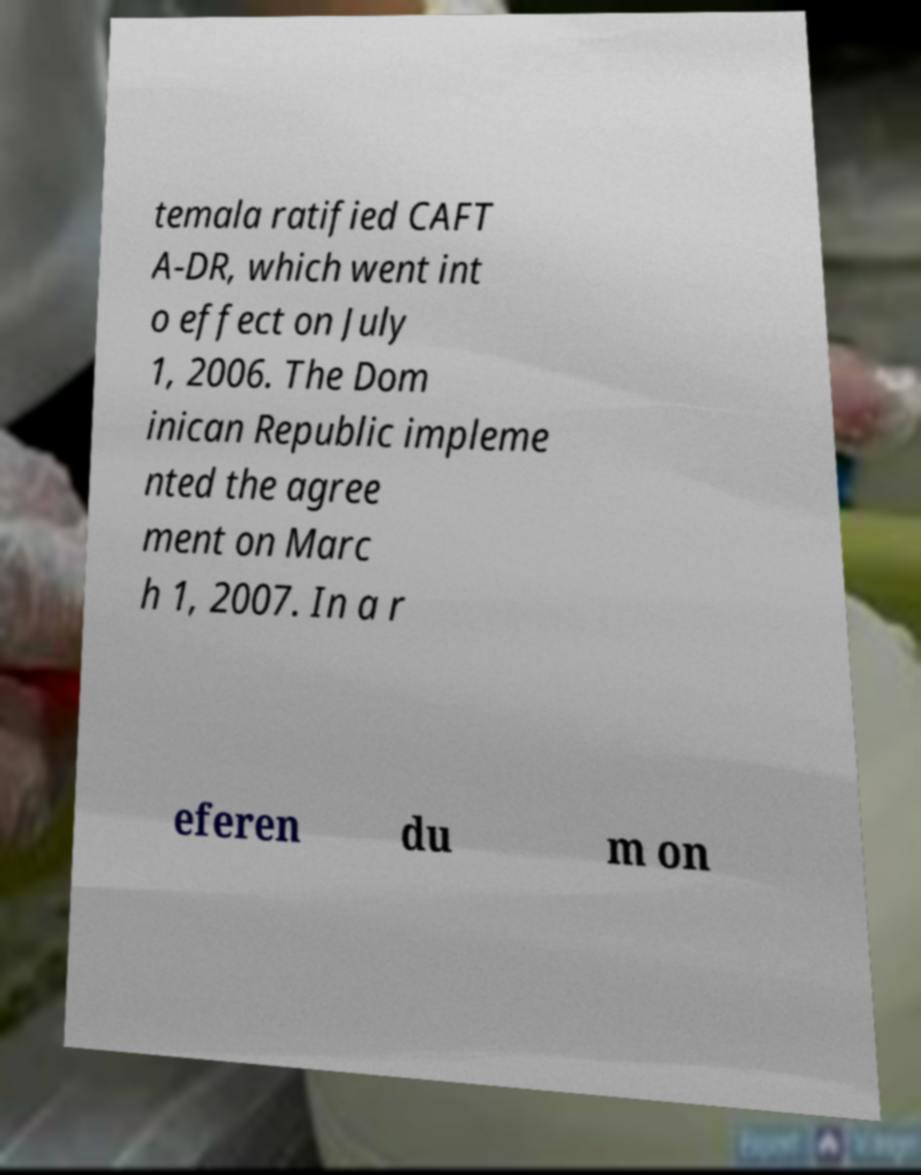Please read and relay the text visible in this image. What does it say? temala ratified CAFT A-DR, which went int o effect on July 1, 2006. The Dom inican Republic impleme nted the agree ment on Marc h 1, 2007. In a r eferen du m on 